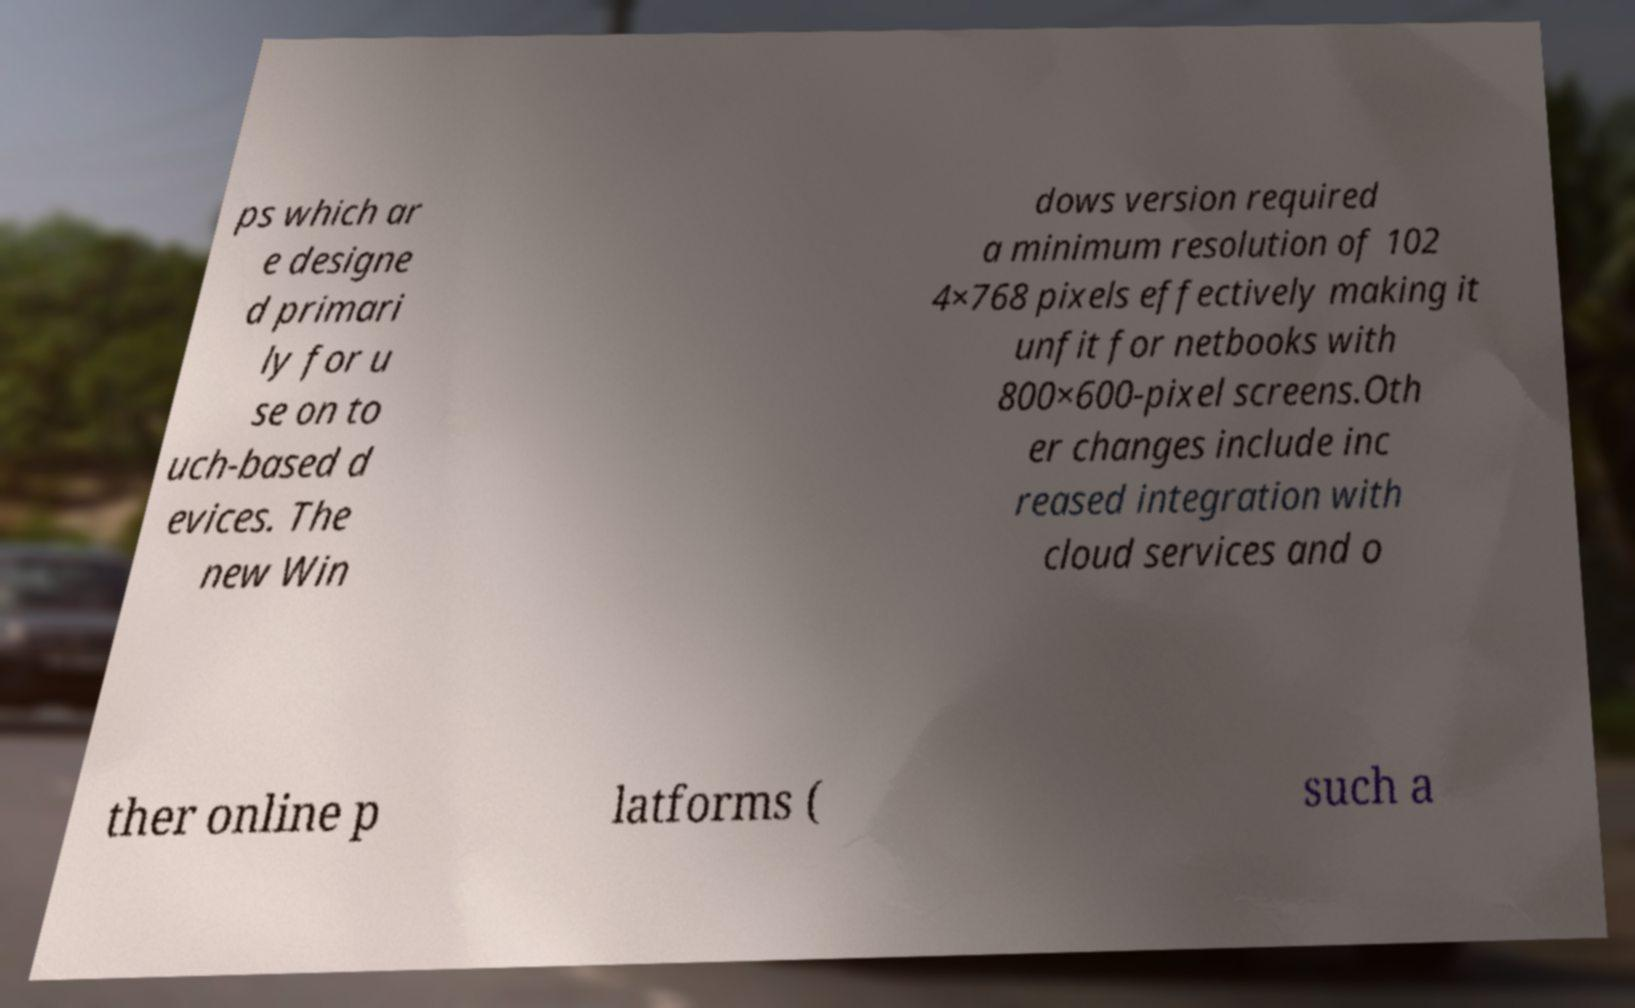Please read and relay the text visible in this image. What does it say? ps which ar e designe d primari ly for u se on to uch-based d evices. The new Win dows version required a minimum resolution of 102 4×768 pixels effectively making it unfit for netbooks with 800×600-pixel screens.Oth er changes include inc reased integration with cloud services and o ther online p latforms ( such a 